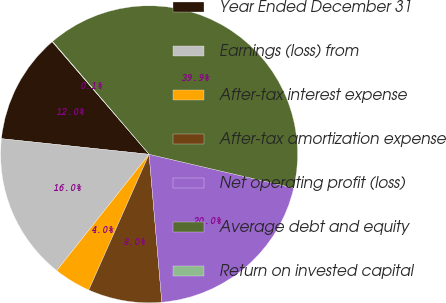Convert chart. <chart><loc_0><loc_0><loc_500><loc_500><pie_chart><fcel>Year Ended December 31<fcel>Earnings (loss) from<fcel>After-tax interest expense<fcel>After-tax amortization expense<fcel>Net operating profit (loss)<fcel>Average debt and equity<fcel>Return on invested capital<nl><fcel>12.01%<fcel>15.99%<fcel>4.03%<fcel>8.02%<fcel>19.98%<fcel>39.91%<fcel>0.05%<nl></chart> 